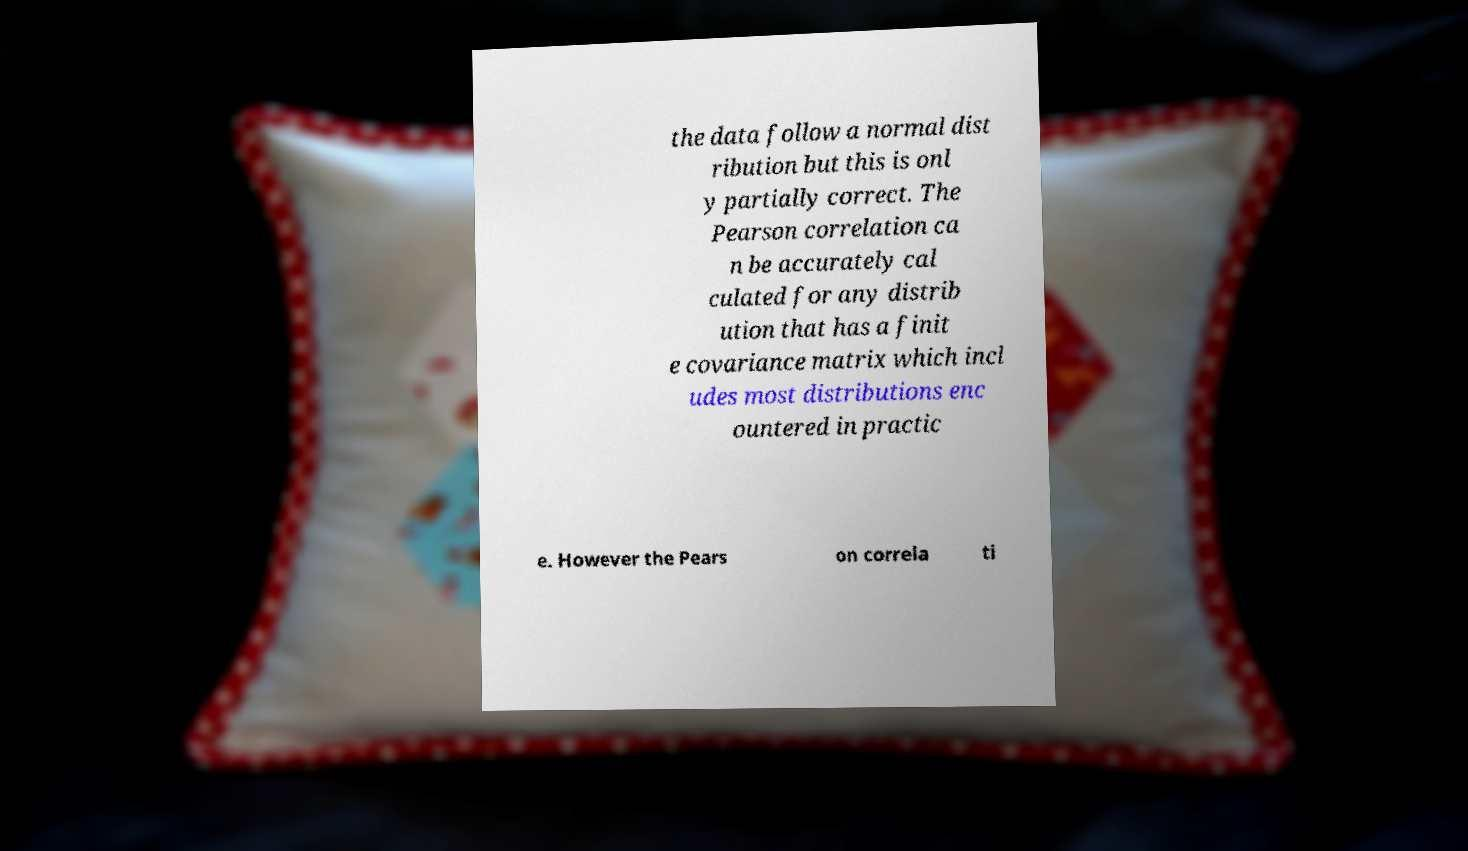Can you read and provide the text displayed in the image?This photo seems to have some interesting text. Can you extract and type it out for me? the data follow a normal dist ribution but this is onl y partially correct. The Pearson correlation ca n be accurately cal culated for any distrib ution that has a finit e covariance matrix which incl udes most distributions enc ountered in practic e. However the Pears on correla ti 